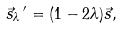<formula> <loc_0><loc_0><loc_500><loc_500>\vec { s } _ { \lambda } \, ^ { \prime } = ( 1 - 2 \lambda ) \vec { s } ,</formula> 